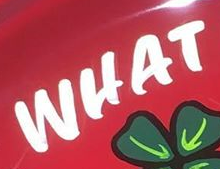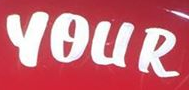What text appears in these images from left to right, separated by a semicolon? WHAT; YOUR 